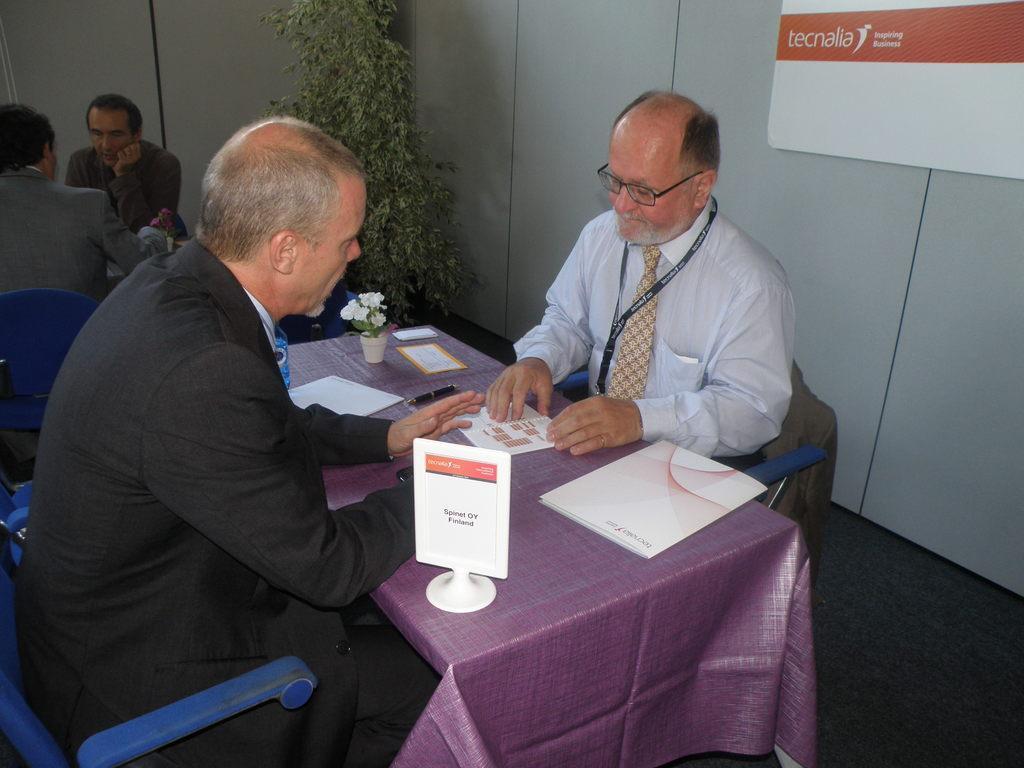How would you summarize this image in a sentence or two? This picture shows two men seated on the chairs and we see some papers on the table and we see two people seated on the other side and we see a plant 